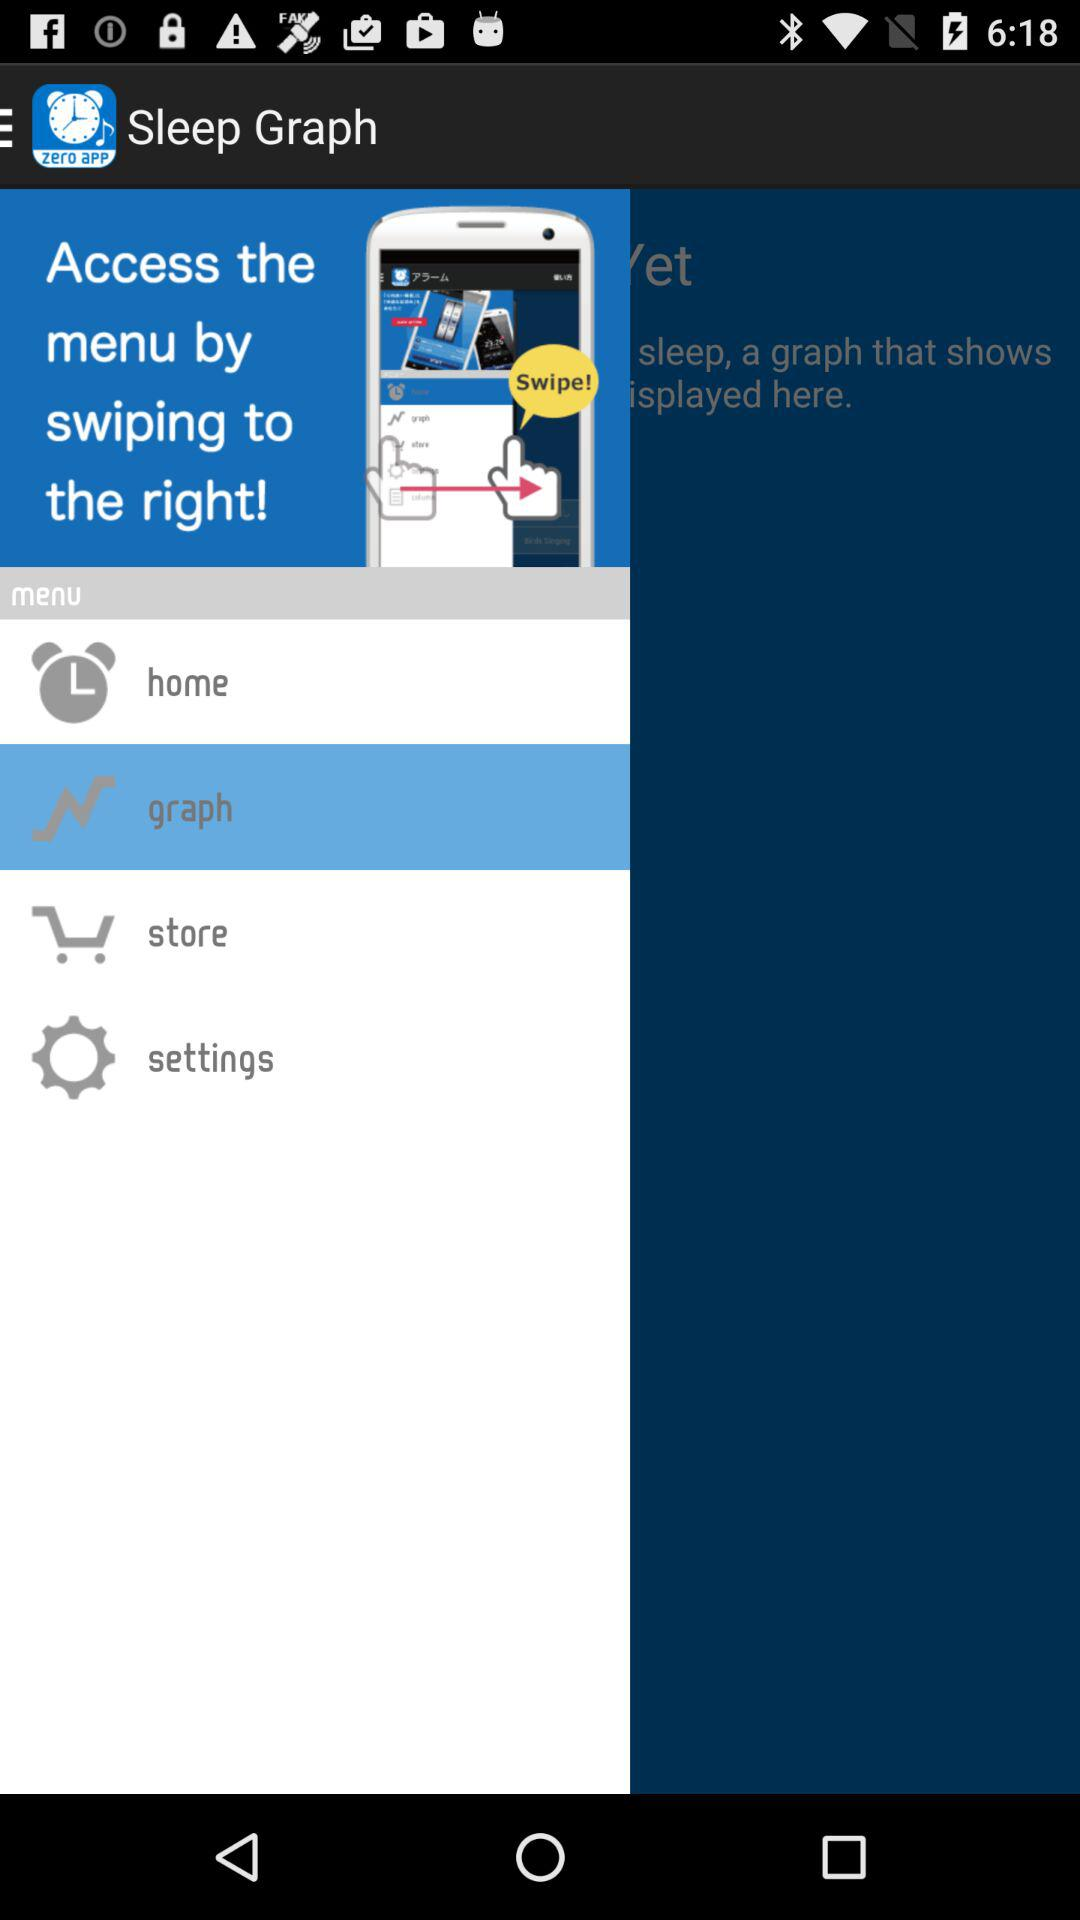How many items are in the menu?
Answer the question using a single word or phrase. 4 